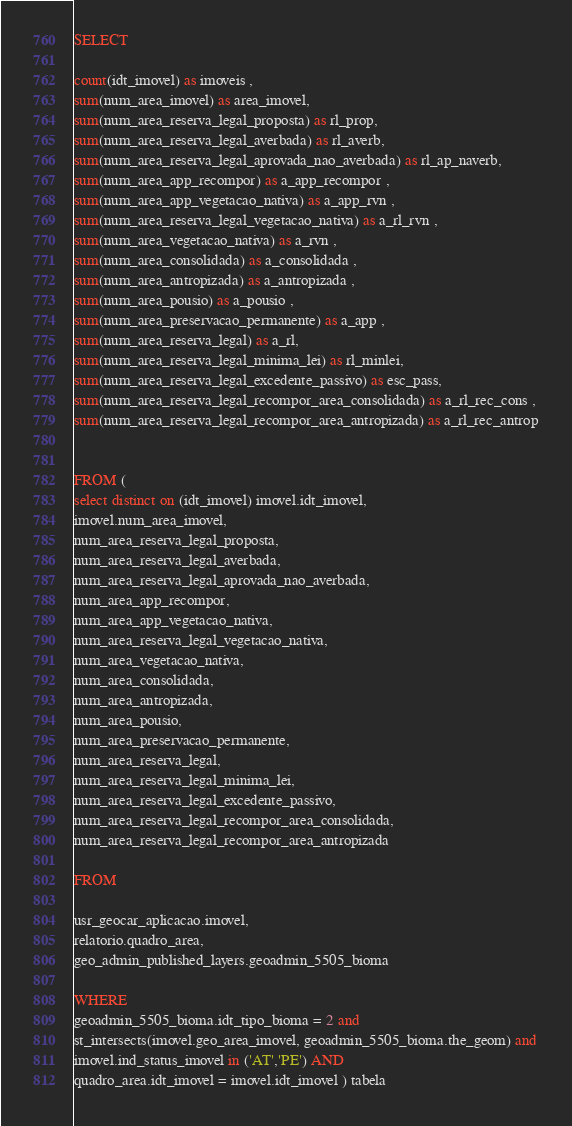Convert code to text. <code><loc_0><loc_0><loc_500><loc_500><_SQL_>SELECT 

count(idt_imovel) as imoveis ,
sum(num_area_imovel) as area_imovel, 
sum(num_area_reserva_legal_proposta) as rl_prop, 
sum(num_area_reserva_legal_averbada) as rl_averb, 
sum(num_area_reserva_legal_aprovada_nao_averbada) as rl_ap_naverb, 
sum(num_area_app_recompor) as a_app_recompor ,
sum(num_area_app_vegetacao_nativa) as a_app_rvn ,
sum(num_area_reserva_legal_vegetacao_nativa) as a_rl_rvn ,
sum(num_area_vegetacao_nativa) as a_rvn ,
sum(num_area_consolidada) as a_consolidada ,
sum(num_area_antropizada) as a_antropizada ,
sum(num_area_pousio) as a_pousio ,
sum(num_area_preservacao_permanente) as a_app ,
sum(num_area_reserva_legal) as a_rl,
sum(num_area_reserva_legal_minima_lei) as rl_minlei, 
sum(num_area_reserva_legal_excedente_passivo) as esc_pass, 
sum(num_area_reserva_legal_recompor_area_consolidada) as a_rl_rec_cons ,
sum(num_area_reserva_legal_recompor_area_antropizada) as a_rl_rec_antrop


FROM (
select distinct on (idt_imovel) imovel.idt_imovel,
imovel.num_area_imovel, 
num_area_reserva_legal_proposta,
num_area_reserva_legal_averbada, 
num_area_reserva_legal_aprovada_nao_averbada,
num_area_app_recompor,
num_area_app_vegetacao_nativa,
num_area_reserva_legal_vegetacao_nativa,
num_area_vegetacao_nativa,
num_area_consolidada,
num_area_antropizada,
num_area_pousio,
num_area_preservacao_permanente,
num_area_reserva_legal,
num_area_reserva_legal_minima_lei,
num_area_reserva_legal_excedente_passivo,
num_area_reserva_legal_recompor_area_consolidada,
num_area_reserva_legal_recompor_area_antropizada

FROM

usr_geocar_aplicacao.imovel, 
relatorio.quadro_area,
geo_admin_published_layers.geoadmin_5505_bioma

WHERE 
geoadmin_5505_bioma.idt_tipo_bioma = 2 and
st_intersects(imovel.geo_area_imovel, geoadmin_5505_bioma.the_geom) and
imovel.ind_status_imovel in ('AT','PE') AND
quadro_area.idt_imovel = imovel.idt_imovel ) tabela
</code> 